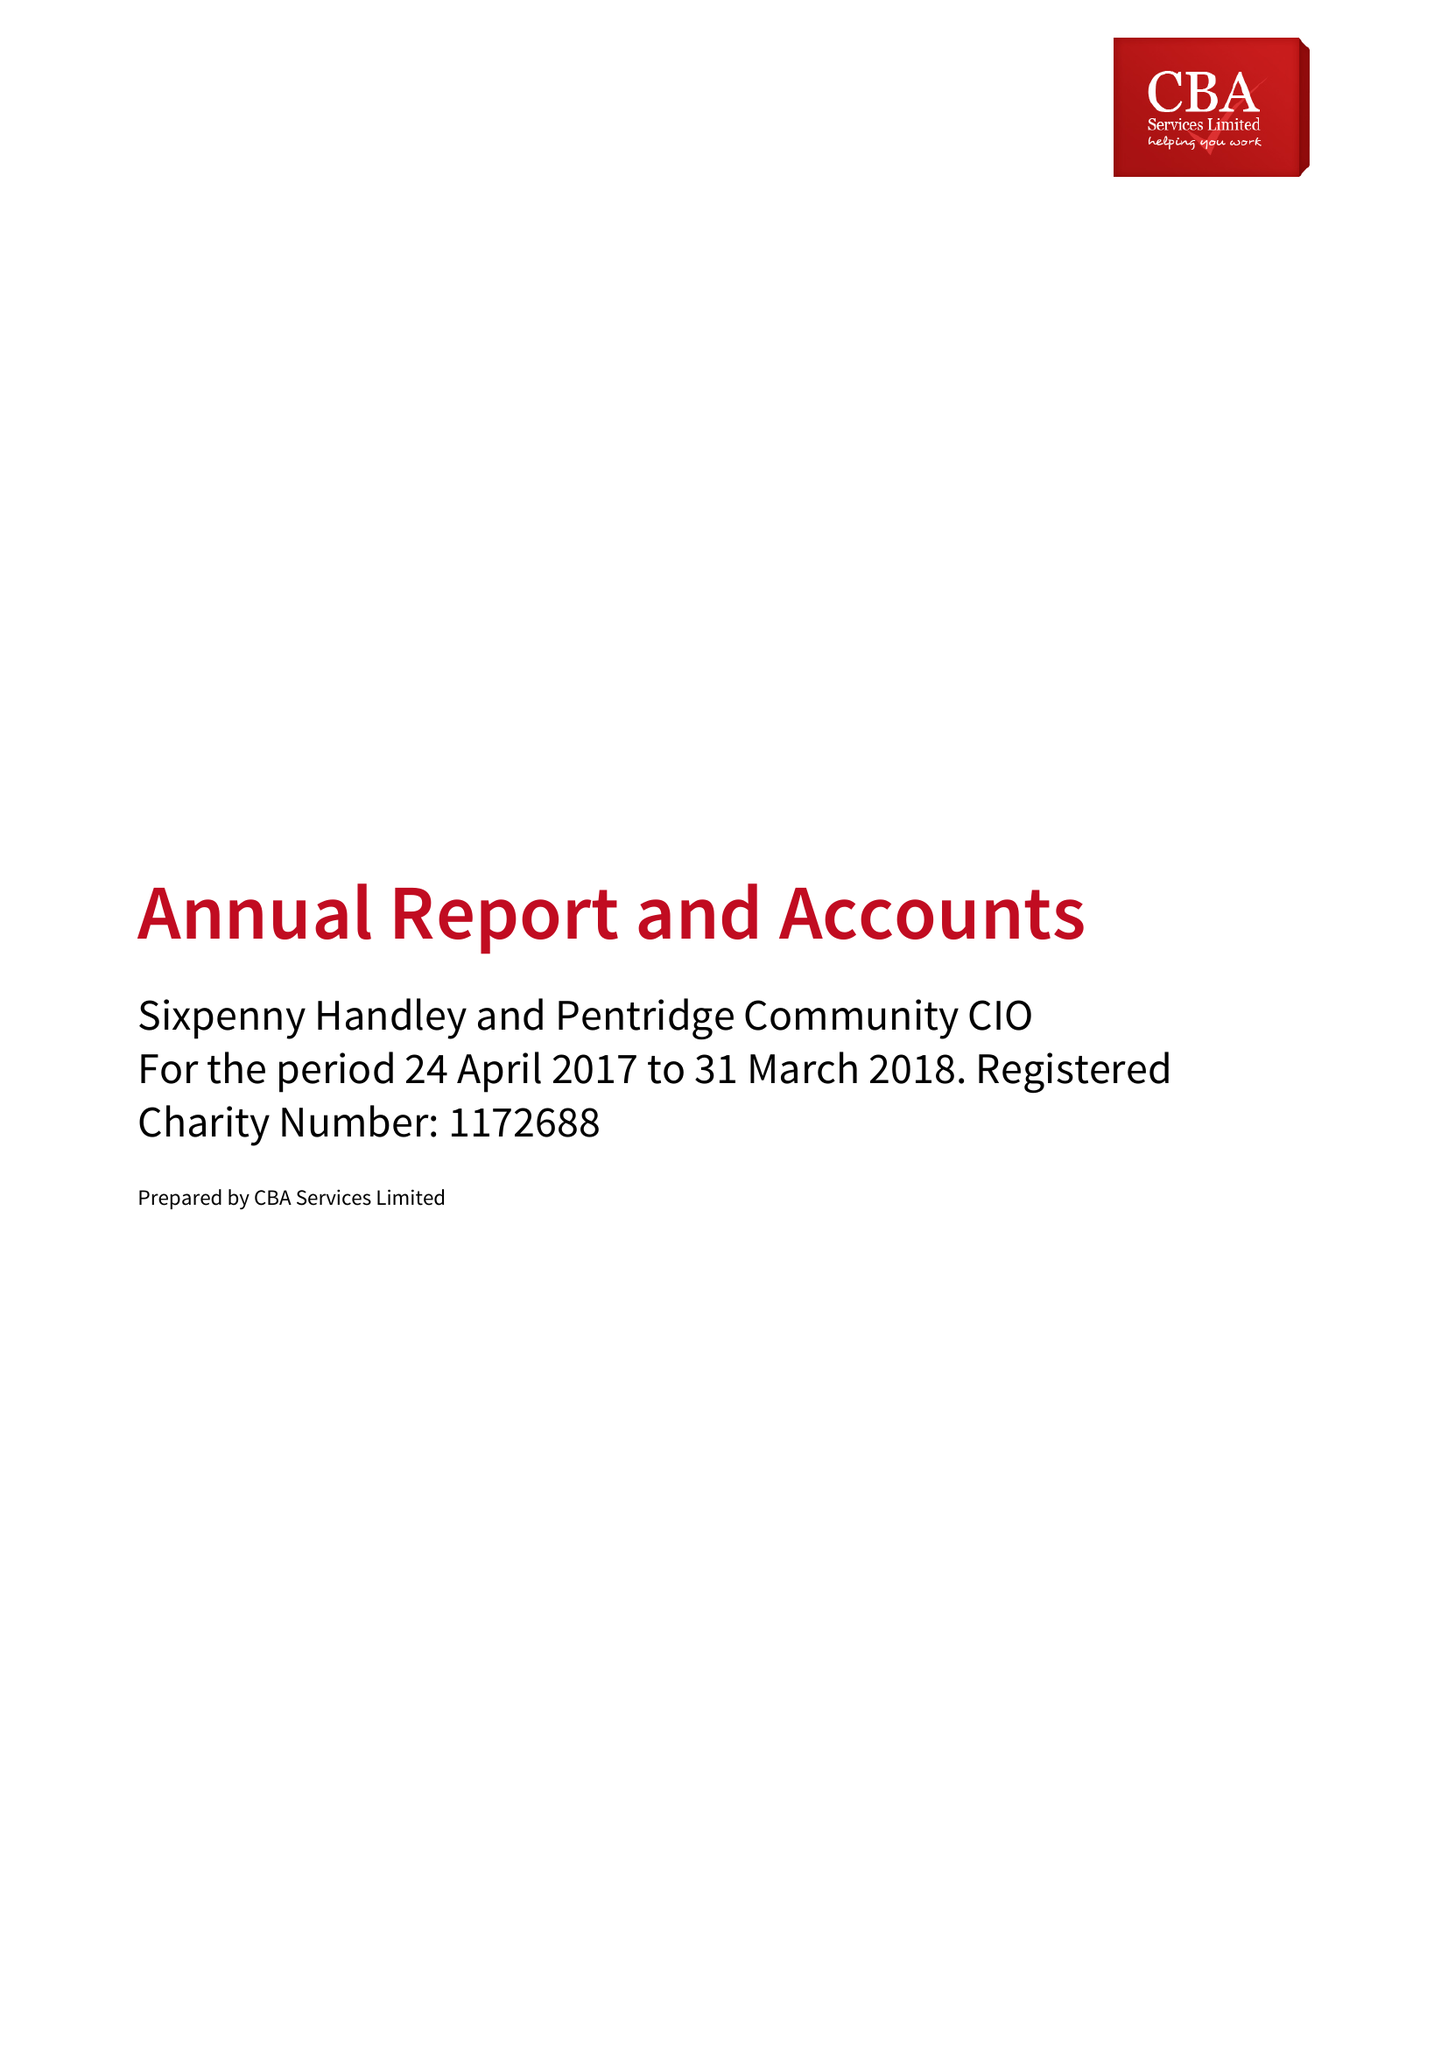What is the value for the charity_name?
Answer the question using a single word or phrase. Sixpenny Handley and Pentridge Community CIO 